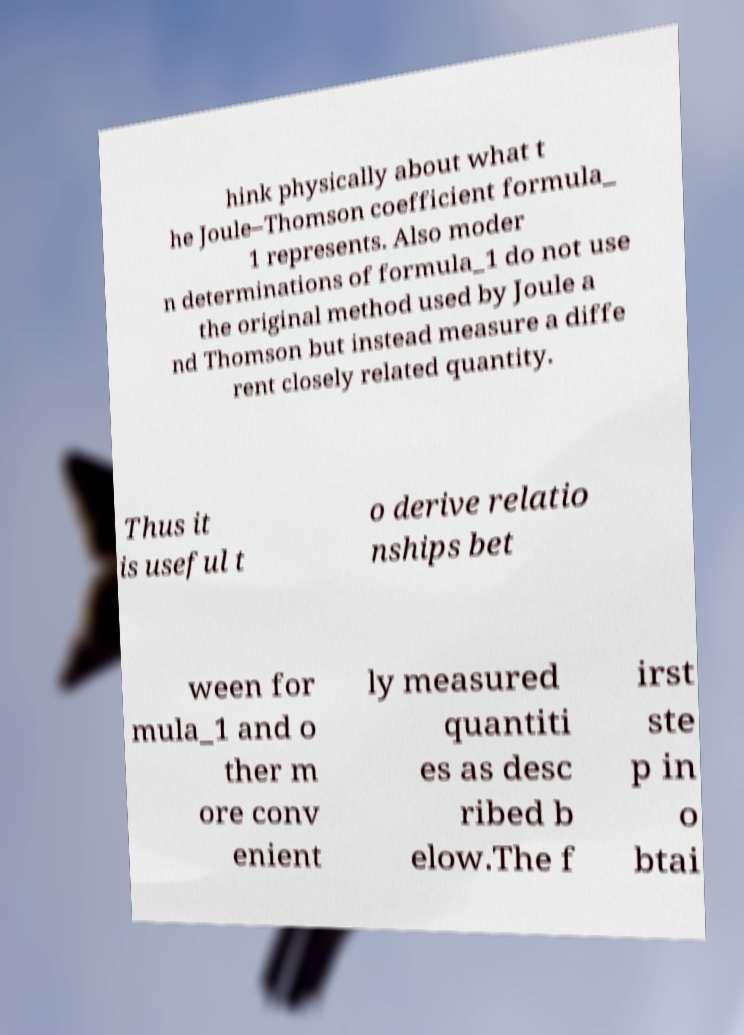There's text embedded in this image that I need extracted. Can you transcribe it verbatim? hink physically about what t he Joule–Thomson coefficient formula_ 1 represents. Also moder n determinations of formula_1 do not use the original method used by Joule a nd Thomson but instead measure a diffe rent closely related quantity. Thus it is useful t o derive relatio nships bet ween for mula_1 and o ther m ore conv enient ly measured quantiti es as desc ribed b elow.The f irst ste p in o btai 